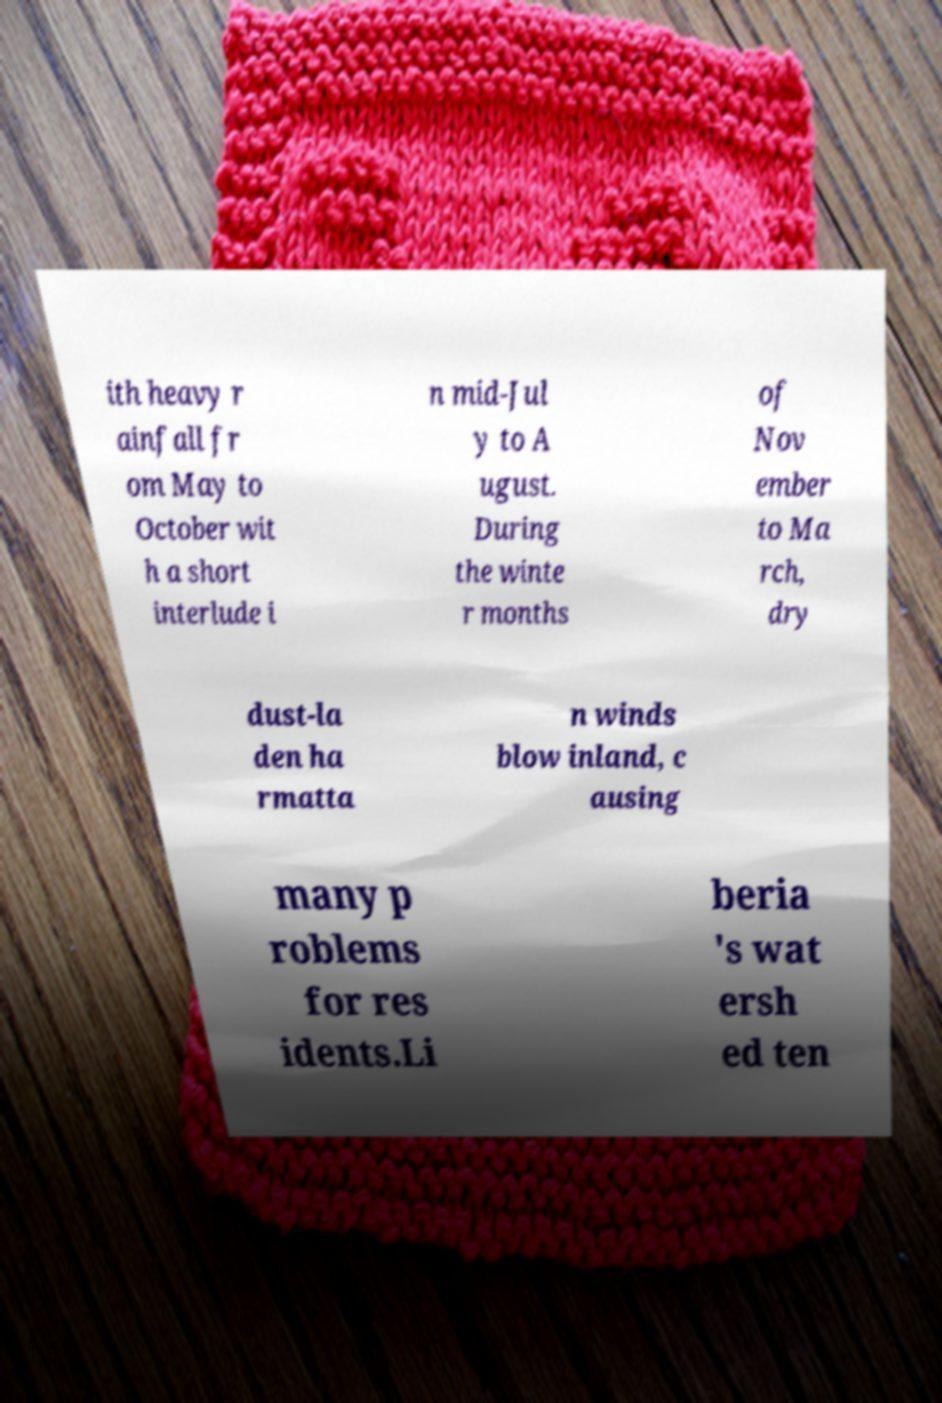Could you extract and type out the text from this image? ith heavy r ainfall fr om May to October wit h a short interlude i n mid-Jul y to A ugust. During the winte r months of Nov ember to Ma rch, dry dust-la den ha rmatta n winds blow inland, c ausing many p roblems for res idents.Li beria 's wat ersh ed ten 